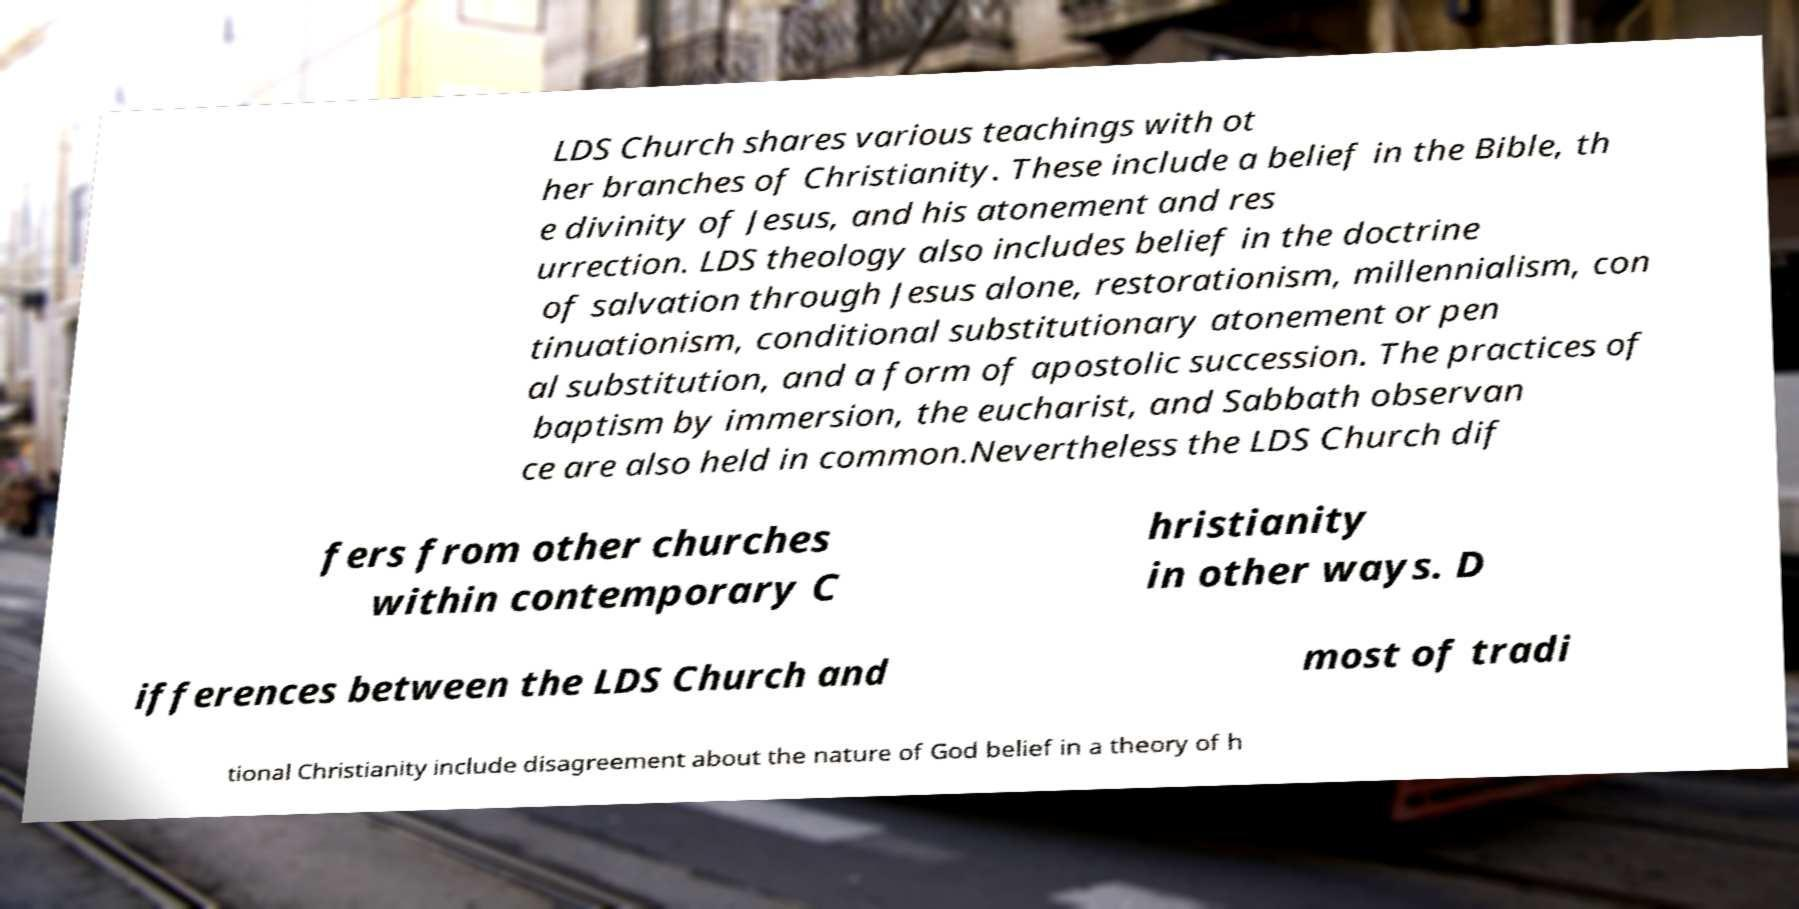Can you accurately transcribe the text from the provided image for me? LDS Church shares various teachings with ot her branches of Christianity. These include a belief in the Bible, th e divinity of Jesus, and his atonement and res urrection. LDS theology also includes belief in the doctrine of salvation through Jesus alone, restorationism, millennialism, con tinuationism, conditional substitutionary atonement or pen al substitution, and a form of apostolic succession. The practices of baptism by immersion, the eucharist, and Sabbath observan ce are also held in common.Nevertheless the LDS Church dif fers from other churches within contemporary C hristianity in other ways. D ifferences between the LDS Church and most of tradi tional Christianity include disagreement about the nature of God belief in a theory of h 